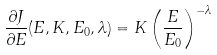Convert formula to latex. <formula><loc_0><loc_0><loc_500><loc_500>\frac { \partial { J } } { \partial { E } } ( E , K , E _ { 0 } , \lambda ) = K \left ( \frac { E } { E _ { 0 } } \right ) ^ { - \lambda }</formula> 